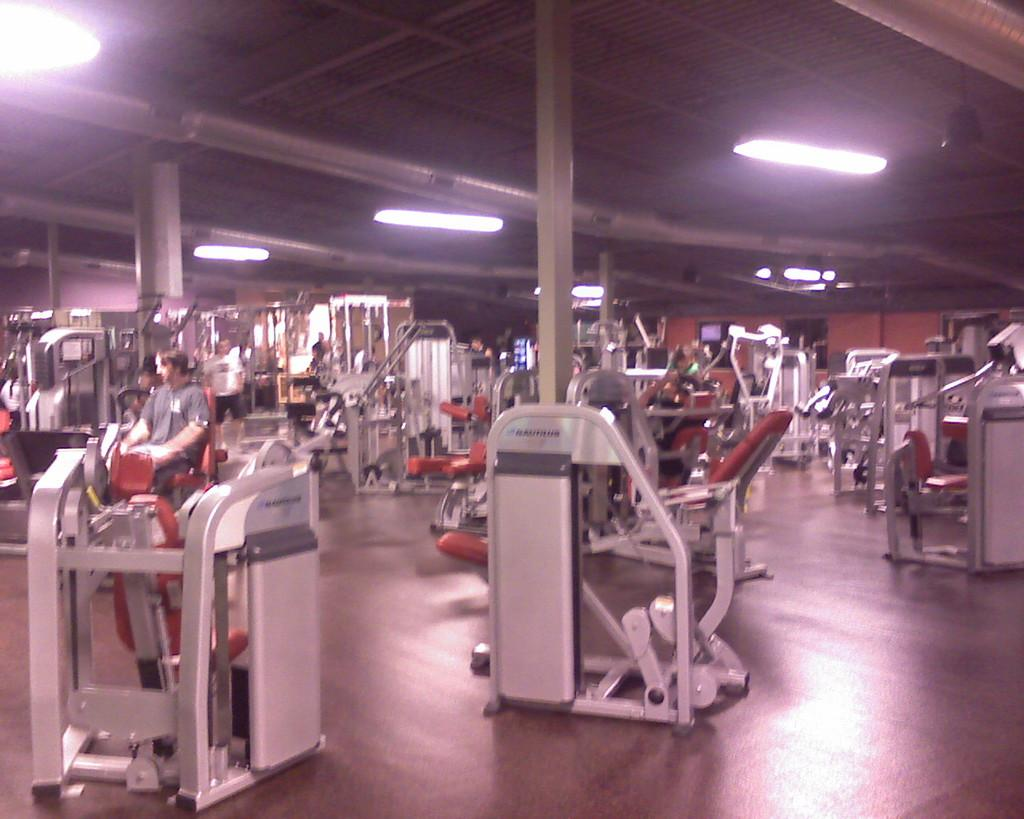What type of objects can be seen in the image? There are machines, chairs, and poles in the image. What is the position of the people in the image? The people are on the floor in the image. What structures are present in the image? There is a wall and a roof in the image. What type of lighting is present in the image? There are ceiling lights in the image. What type of pet can be seen playing with a quartz crystal in the image? There is no pet or quartz crystal present in the image. How does the drop of water fall from the ceiling in the image? There is no drop of water falling from the ceiling in the image. 